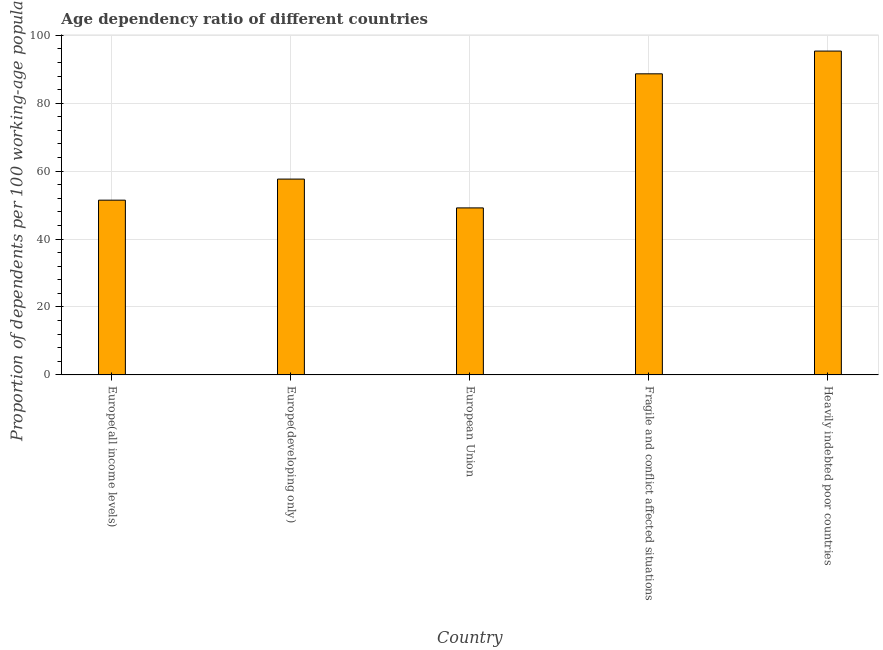What is the title of the graph?
Provide a succinct answer. Age dependency ratio of different countries. What is the label or title of the Y-axis?
Provide a succinct answer. Proportion of dependents per 100 working-age population. What is the age dependency ratio in Heavily indebted poor countries?
Offer a very short reply. 95.36. Across all countries, what is the maximum age dependency ratio?
Keep it short and to the point. 95.36. Across all countries, what is the minimum age dependency ratio?
Your response must be concise. 49.18. In which country was the age dependency ratio maximum?
Provide a short and direct response. Heavily indebted poor countries. What is the sum of the age dependency ratio?
Your answer should be very brief. 342.32. What is the difference between the age dependency ratio in Europe(all income levels) and Heavily indebted poor countries?
Your answer should be compact. -43.91. What is the average age dependency ratio per country?
Give a very brief answer. 68.46. What is the median age dependency ratio?
Ensure brevity in your answer.  57.66. What is the ratio of the age dependency ratio in Europe(developing only) to that in Heavily indebted poor countries?
Your answer should be compact. 0.6. What is the difference between the highest and the second highest age dependency ratio?
Give a very brief answer. 6.7. Is the sum of the age dependency ratio in Europe(all income levels) and Fragile and conflict affected situations greater than the maximum age dependency ratio across all countries?
Offer a terse response. Yes. What is the difference between the highest and the lowest age dependency ratio?
Make the answer very short. 46.18. In how many countries, is the age dependency ratio greater than the average age dependency ratio taken over all countries?
Your answer should be very brief. 2. How many bars are there?
Give a very brief answer. 5. How many countries are there in the graph?
Your response must be concise. 5. What is the difference between two consecutive major ticks on the Y-axis?
Make the answer very short. 20. What is the Proportion of dependents per 100 working-age population in Europe(all income levels)?
Provide a short and direct response. 51.46. What is the Proportion of dependents per 100 working-age population of Europe(developing only)?
Keep it short and to the point. 57.66. What is the Proportion of dependents per 100 working-age population in European Union?
Ensure brevity in your answer.  49.18. What is the Proportion of dependents per 100 working-age population of Fragile and conflict affected situations?
Keep it short and to the point. 88.66. What is the Proportion of dependents per 100 working-age population in Heavily indebted poor countries?
Make the answer very short. 95.36. What is the difference between the Proportion of dependents per 100 working-age population in Europe(all income levels) and Europe(developing only)?
Give a very brief answer. -6.21. What is the difference between the Proportion of dependents per 100 working-age population in Europe(all income levels) and European Union?
Offer a terse response. 2.28. What is the difference between the Proportion of dependents per 100 working-age population in Europe(all income levels) and Fragile and conflict affected situations?
Ensure brevity in your answer.  -37.2. What is the difference between the Proportion of dependents per 100 working-age population in Europe(all income levels) and Heavily indebted poor countries?
Provide a short and direct response. -43.9. What is the difference between the Proportion of dependents per 100 working-age population in Europe(developing only) and European Union?
Make the answer very short. 8.48. What is the difference between the Proportion of dependents per 100 working-age population in Europe(developing only) and Fragile and conflict affected situations?
Make the answer very short. -31. What is the difference between the Proportion of dependents per 100 working-age population in Europe(developing only) and Heavily indebted poor countries?
Keep it short and to the point. -37.7. What is the difference between the Proportion of dependents per 100 working-age population in European Union and Fragile and conflict affected situations?
Your response must be concise. -39.48. What is the difference between the Proportion of dependents per 100 working-age population in European Union and Heavily indebted poor countries?
Your response must be concise. -46.18. What is the difference between the Proportion of dependents per 100 working-age population in Fragile and conflict affected situations and Heavily indebted poor countries?
Make the answer very short. -6.7. What is the ratio of the Proportion of dependents per 100 working-age population in Europe(all income levels) to that in Europe(developing only)?
Your answer should be very brief. 0.89. What is the ratio of the Proportion of dependents per 100 working-age population in Europe(all income levels) to that in European Union?
Your answer should be compact. 1.05. What is the ratio of the Proportion of dependents per 100 working-age population in Europe(all income levels) to that in Fragile and conflict affected situations?
Give a very brief answer. 0.58. What is the ratio of the Proportion of dependents per 100 working-age population in Europe(all income levels) to that in Heavily indebted poor countries?
Offer a very short reply. 0.54. What is the ratio of the Proportion of dependents per 100 working-age population in Europe(developing only) to that in European Union?
Your answer should be compact. 1.17. What is the ratio of the Proportion of dependents per 100 working-age population in Europe(developing only) to that in Fragile and conflict affected situations?
Give a very brief answer. 0.65. What is the ratio of the Proportion of dependents per 100 working-age population in Europe(developing only) to that in Heavily indebted poor countries?
Your answer should be very brief. 0.6. What is the ratio of the Proportion of dependents per 100 working-age population in European Union to that in Fragile and conflict affected situations?
Provide a short and direct response. 0.56. What is the ratio of the Proportion of dependents per 100 working-age population in European Union to that in Heavily indebted poor countries?
Provide a short and direct response. 0.52. 